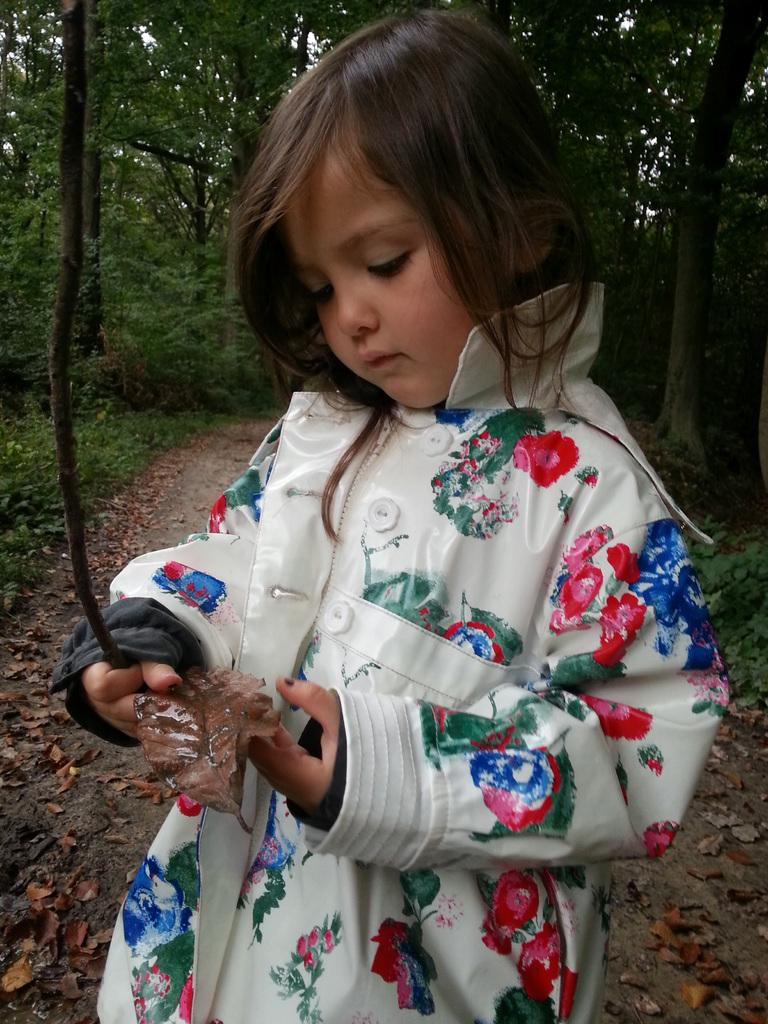Who is the main subject in the image? There is a girl in the image. What is the girl doing in the image? The girl is standing on the road and holding a stick and a leaf. What can be seen in the background of the image? There are trees in the background of the image. What type of bell can be heard ringing in the image? There is no bell present in the image, and therefore no sound can be heard. 